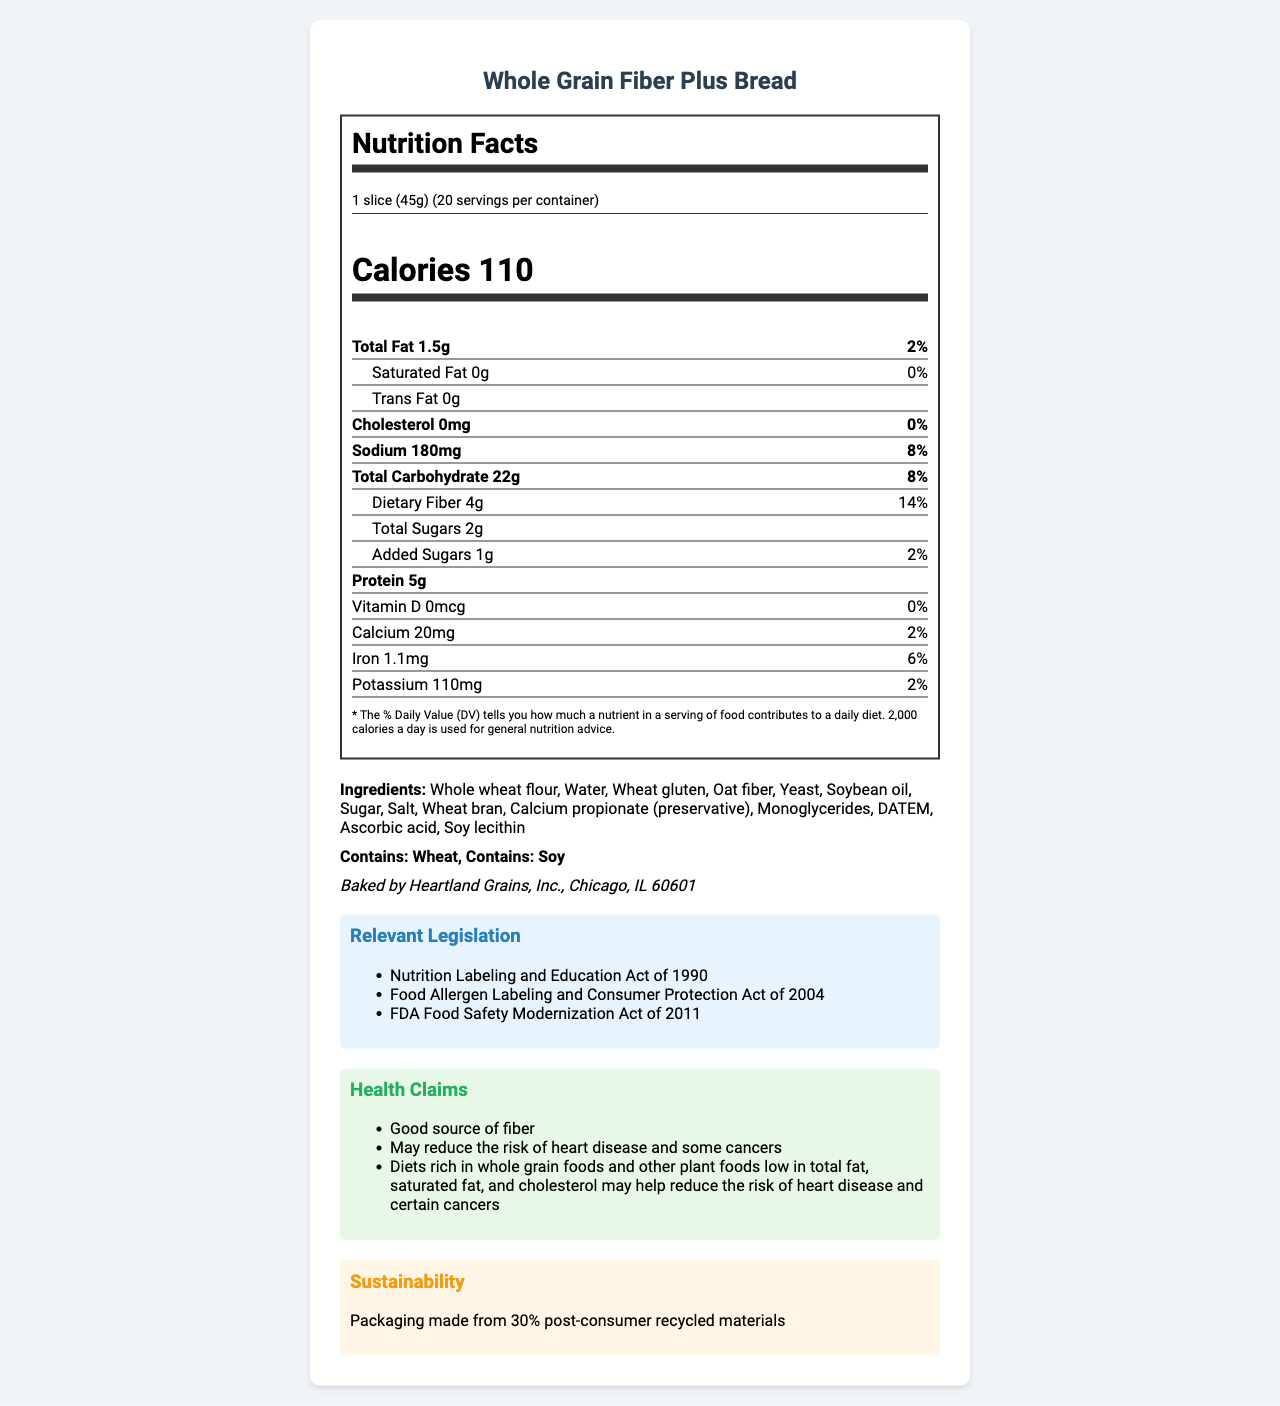what is the serving size for the Whole Grain Fiber Plus Bread? The serving size is clearly indicated at the top of the nutrition label as "1 slice (45g)".
Answer: 1 slice (45g) how many servings are there per container? The number of servings per container is stated right below the serving size on the nutrition label.
Answer: 20 what is the total carbohydrate content per serving? Under the "Total Carbohydrate" section of the nutrition label, it lists the amount as "22g".
Answer: 22g how much dietary fiber is in each serving and what percentage of the daily value does this represent? The dietary fiber content is listed under the "Total Carbohydrate" section as "4g" and the percent daily value is "14%".
Answer: 4g, 14% how many different ingredients are used in Whole Grain Fiber Plus Bread? By counting the items listed under the "Ingredients" section, there are a total of 14 different ingredients.
Answer: 14 which of the following nutrients does the bread contain no amount of? A. Saturated Fat B. Trans Fat C. Vitamin D D. All of the above Saturated Fat, Trans Fat, and Vitamin D are all listed as "0" amounts in their respective sections.
Answer: D. All of the above what is the calorie count per serving for Whole Grain Fiber Plus Bread? Calories per serving are stated prominently on the nutrition label as "Calories 110".
Answer: 110 does the bread contain any allergens? If so, what are they? In the allergens section, it states "Contains: Wheat" and "Contains: Soy".
Answer: Yes, wheat and soy which act mandates the presence of the allergy information on the label? A. Nutrition Labeling and Education Act of 1990 B. Food Allergen Labeling and Consumer Protection Act of 2004 C. FDA Food Safety Modernization Act of 2011 The relevant legislation section mentions that the Food Allergen Labeling and Consumer Protection Act of 2004 mandates allergy information.
Answer: B. Food Allergen Labeling and Consumer Protection Act of 2004 is this bread a good source of fiber? The health claims section states that it is a "Good source of fiber".
Answer: Yes what are the health benefits claimed on the bread's label? The health claims section includes the statement that the bread "May reduce the risk of heart disease and some cancers".
Answer: May reduce the risk of heart disease and some cancers is any information provided about sustainability efforts for this product? The sustainability section notes that the packaging is made from 30% post-consumer recycled materials.
Answer: Yes can you confirm the manufacturer's location? The manufacturer information states that the bread is baked by Heartland Grains, Inc., located in Chicago, IL 60601.
Answer: Chicago, IL 60601 what are the percentage daily values for calcium and iron per serving? The nutrition label lists calcium at 2% daily value and iron at 6% daily value.
Answer: Calcium 2%, Iron 6% what is the main idea of this document? The document includes comprehensive nutritional data, lists the ingredients, highlights health benefits, mentions allergy warnings, and describes environmental sustainability measures.
Answer: The document provides detailed nutritional information, ingredients, health claims, allergen warnings, and sustainability efforts for Whole Grain Fiber Plus Bread. what is the exact amount of potassium in each serving? The nutrition label indicates that there are 110mg of potassium per serving.
Answer: 110mg can you provide the % DV for protein? The nutrition label includes the amount of protein per serving (5g) but does not provide a % daily value for protein.
Answer: Not provided what is the sodium content, and what percentage does it contribute to the daily value? The nutrition label indicates that the sodium content per serving is 180mg, which is 8% of the daily value.
Answer: 180mg, 8% does the label indicate any presence of GMO ingredients? The document does not provide any specific details about whether the ingredients are GMO or non-GMO.
Answer: Not enough information 